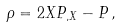Convert formula to latex. <formula><loc_0><loc_0><loc_500><loc_500>\rho = 2 X P _ { , X } - P \, ,</formula> 